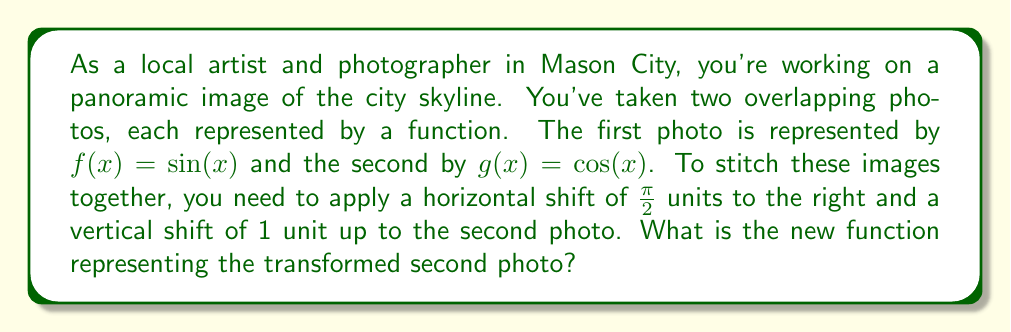Help me with this question. To solve this problem, we'll apply the horizontal and vertical shifts to the function $g(x) = \cos(x)$ step by step:

1. Horizontal shift:
   - To shift a function horizontally to the right by $h$ units, we replace $x$ with $(x - h)$.
   - In this case, $h = \frac{\pi}{2}$, so we replace $x$ with $(x - \frac{\pi}{2})$.
   - The function becomes: $\cos(x - \frac{\pi}{2})$

2. Vertical shift:
   - To shift a function vertically up by $k$ units, we add $k$ to the function.
   - In this case, $k = 1$, so we add 1 to the function.
   - The function becomes: $\cos(x - \frac{\pi}{2}) + 1$

3. Combining the shifts:
   - The final transformed function is: $g_{new}(x) = \cos(x - \frac{\pi}{2}) + 1$

This new function represents the second photo after applying both the horizontal and vertical shifts required for stitching the panoramic image.
Answer: $g_{new}(x) = \cos(x - \frac{\pi}{2}) + 1$ 